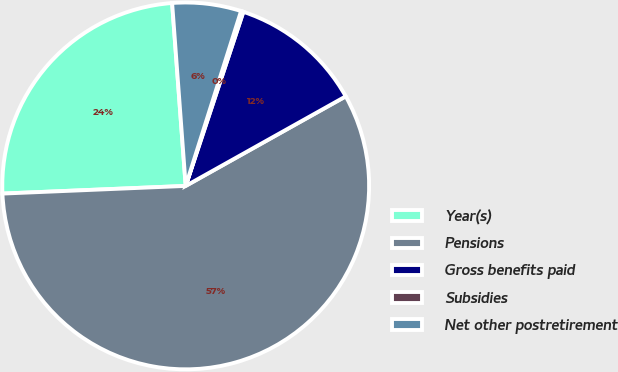<chart> <loc_0><loc_0><loc_500><loc_500><pie_chart><fcel>Year(s)<fcel>Pensions<fcel>Gross benefits paid<fcel>Subsidies<fcel>Net other postretirement<nl><fcel>24.49%<fcel>57.46%<fcel>11.79%<fcel>0.21%<fcel>6.06%<nl></chart> 